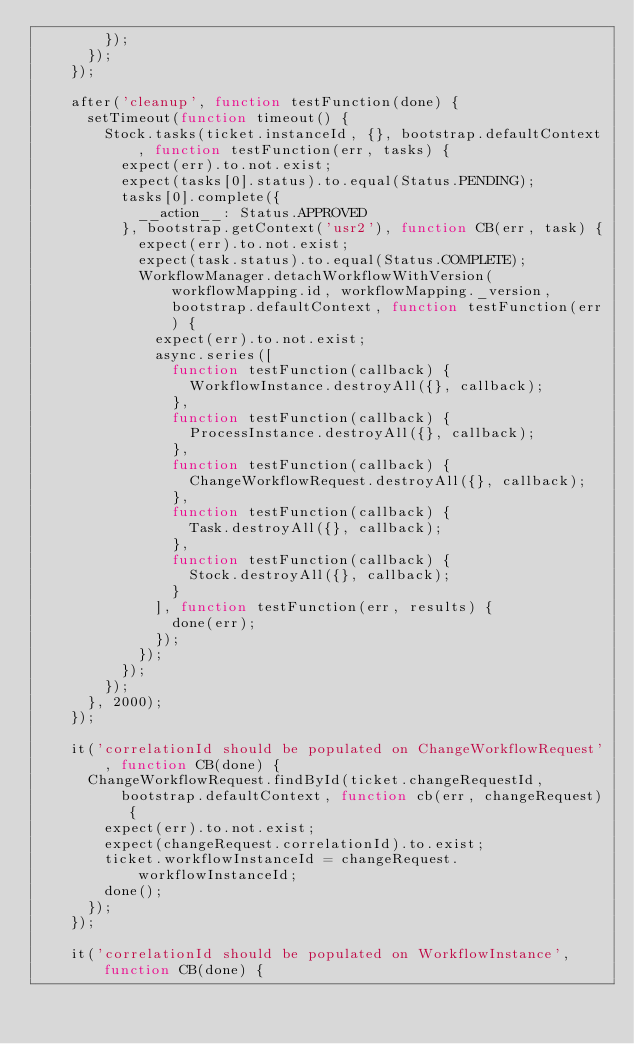Convert code to text. <code><loc_0><loc_0><loc_500><loc_500><_JavaScript_>        });
      });
    });

    after('cleanup', function testFunction(done) {
      setTimeout(function timeout() {
        Stock.tasks(ticket.instanceId, {}, bootstrap.defaultContext, function testFunction(err, tasks) {
          expect(err).to.not.exist;
          expect(tasks[0].status).to.equal(Status.PENDING);
          tasks[0].complete({
            __action__: Status.APPROVED
          }, bootstrap.getContext('usr2'), function CB(err, task) {
            expect(err).to.not.exist;
            expect(task.status).to.equal(Status.COMPLETE);
            WorkflowManager.detachWorkflowWithVersion(workflowMapping.id, workflowMapping._version, bootstrap.defaultContext, function testFunction(err) {
              expect(err).to.not.exist;
              async.series([
                function testFunction(callback) {
                  WorkflowInstance.destroyAll({}, callback);
                },
                function testFunction(callback) {
                  ProcessInstance.destroyAll({}, callback);
                },
                function testFunction(callback) {
                  ChangeWorkflowRequest.destroyAll({}, callback);
                },
                function testFunction(callback) {
                  Task.destroyAll({}, callback);
                },
                function testFunction(callback) {
                  Stock.destroyAll({}, callback);
                }
              ], function testFunction(err, results) {
                done(err);
              });
            });
          });
        });
      }, 2000);
    });

    it('correlationId should be populated on ChangeWorkflowRequest', function CB(done) {
      ChangeWorkflowRequest.findById(ticket.changeRequestId, bootstrap.defaultContext, function cb(err, changeRequest) {
        expect(err).to.not.exist;
        expect(changeRequest.correlationId).to.exist;
        ticket.workflowInstanceId = changeRequest.workflowInstanceId;
        done();
      });
    });

    it('correlationId should be populated on WorkflowInstance', function CB(done) {</code> 